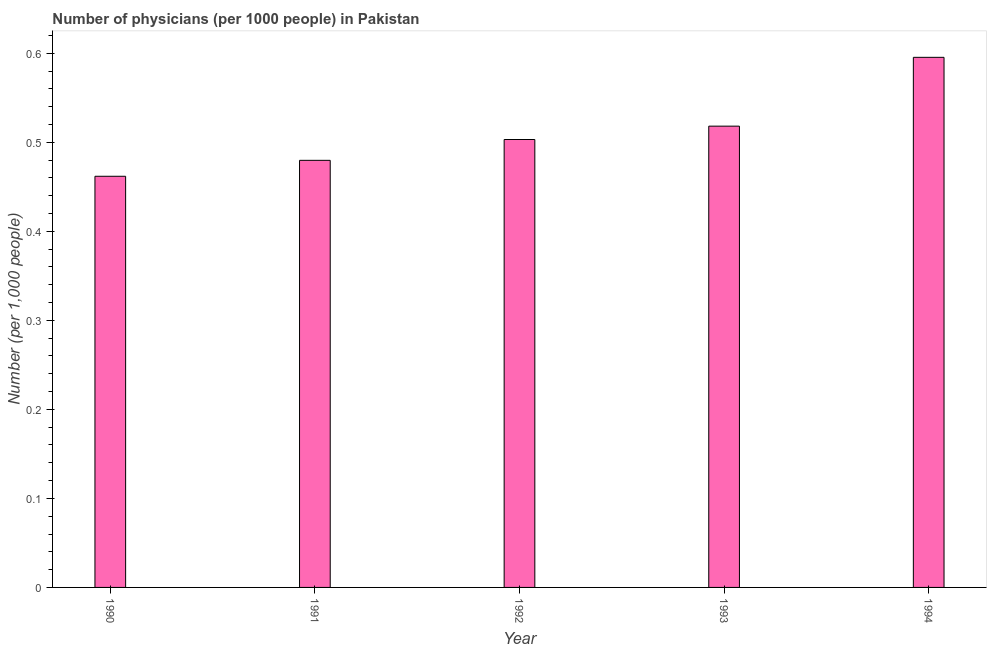Does the graph contain any zero values?
Ensure brevity in your answer.  No. Does the graph contain grids?
Offer a terse response. No. What is the title of the graph?
Ensure brevity in your answer.  Number of physicians (per 1000 people) in Pakistan. What is the label or title of the X-axis?
Your answer should be compact. Year. What is the label or title of the Y-axis?
Give a very brief answer. Number (per 1,0 people). What is the number of physicians in 1994?
Provide a short and direct response. 0.6. Across all years, what is the maximum number of physicians?
Your answer should be very brief. 0.6. Across all years, what is the minimum number of physicians?
Give a very brief answer. 0.46. What is the sum of the number of physicians?
Offer a very short reply. 2.56. What is the difference between the number of physicians in 1990 and 1994?
Your answer should be compact. -0.13. What is the average number of physicians per year?
Your response must be concise. 0.51. What is the median number of physicians?
Your response must be concise. 0.5. What is the ratio of the number of physicians in 1990 to that in 1992?
Give a very brief answer. 0.92. Is the number of physicians in 1992 less than that in 1993?
Provide a short and direct response. Yes. What is the difference between the highest and the second highest number of physicians?
Provide a short and direct response. 0.08. Is the sum of the number of physicians in 1991 and 1993 greater than the maximum number of physicians across all years?
Give a very brief answer. Yes. What is the difference between the highest and the lowest number of physicians?
Your response must be concise. 0.13. In how many years, is the number of physicians greater than the average number of physicians taken over all years?
Your response must be concise. 2. How many years are there in the graph?
Offer a very short reply. 5. What is the difference between two consecutive major ticks on the Y-axis?
Ensure brevity in your answer.  0.1. Are the values on the major ticks of Y-axis written in scientific E-notation?
Your response must be concise. No. What is the Number (per 1,000 people) of 1990?
Offer a terse response. 0.46. What is the Number (per 1,000 people) of 1991?
Ensure brevity in your answer.  0.48. What is the Number (per 1,000 people) in 1992?
Your answer should be compact. 0.5. What is the Number (per 1,000 people) of 1993?
Offer a very short reply. 0.52. What is the Number (per 1,000 people) in 1994?
Your answer should be very brief. 0.6. What is the difference between the Number (per 1,000 people) in 1990 and 1991?
Provide a succinct answer. -0.02. What is the difference between the Number (per 1,000 people) in 1990 and 1992?
Your answer should be compact. -0.04. What is the difference between the Number (per 1,000 people) in 1990 and 1993?
Ensure brevity in your answer.  -0.06. What is the difference between the Number (per 1,000 people) in 1990 and 1994?
Give a very brief answer. -0.13. What is the difference between the Number (per 1,000 people) in 1991 and 1992?
Ensure brevity in your answer.  -0.02. What is the difference between the Number (per 1,000 people) in 1991 and 1993?
Provide a succinct answer. -0.04. What is the difference between the Number (per 1,000 people) in 1991 and 1994?
Provide a short and direct response. -0.12. What is the difference between the Number (per 1,000 people) in 1992 and 1993?
Your answer should be compact. -0.01. What is the difference between the Number (per 1,000 people) in 1992 and 1994?
Ensure brevity in your answer.  -0.09. What is the difference between the Number (per 1,000 people) in 1993 and 1994?
Offer a terse response. -0.08. What is the ratio of the Number (per 1,000 people) in 1990 to that in 1992?
Give a very brief answer. 0.92. What is the ratio of the Number (per 1,000 people) in 1990 to that in 1993?
Give a very brief answer. 0.89. What is the ratio of the Number (per 1,000 people) in 1990 to that in 1994?
Your answer should be very brief. 0.78. What is the ratio of the Number (per 1,000 people) in 1991 to that in 1992?
Your response must be concise. 0.95. What is the ratio of the Number (per 1,000 people) in 1991 to that in 1993?
Your answer should be compact. 0.93. What is the ratio of the Number (per 1,000 people) in 1991 to that in 1994?
Keep it short and to the point. 0.81. What is the ratio of the Number (per 1,000 people) in 1992 to that in 1994?
Your answer should be very brief. 0.84. What is the ratio of the Number (per 1,000 people) in 1993 to that in 1994?
Your response must be concise. 0.87. 